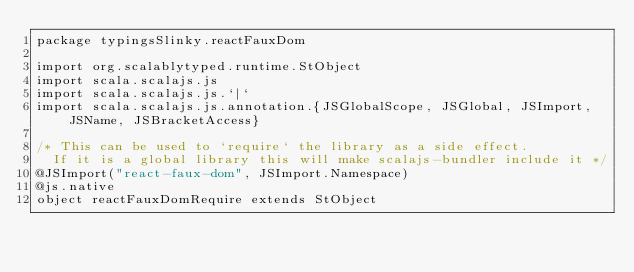Convert code to text. <code><loc_0><loc_0><loc_500><loc_500><_Scala_>package typingsSlinky.reactFauxDom

import org.scalablytyped.runtime.StObject
import scala.scalajs.js
import scala.scalajs.js.`|`
import scala.scalajs.js.annotation.{JSGlobalScope, JSGlobal, JSImport, JSName, JSBracketAccess}

/* This can be used to `require` the library as a side effect.
  If it is a global library this will make scalajs-bundler include it */
@JSImport("react-faux-dom", JSImport.Namespace)
@js.native
object reactFauxDomRequire extends StObject
</code> 